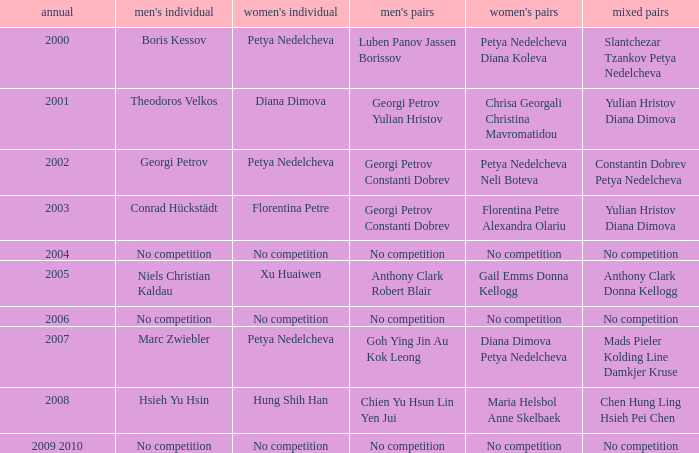Write the full table. {'header': ['annual', "men's individual", "women's individual", "men's pairs", "women's pairs", 'mixed pairs'], 'rows': [['2000', 'Boris Kessov', 'Petya Nedelcheva', 'Luben Panov Jassen Borissov', 'Petya Nedelcheva Diana Koleva', 'Slantchezar Tzankov Petya Nedelcheva'], ['2001', 'Theodoros Velkos', 'Diana Dimova', 'Georgi Petrov Yulian Hristov', 'Chrisa Georgali Christina Mavromatidou', 'Yulian Hristov Diana Dimova'], ['2002', 'Georgi Petrov', 'Petya Nedelcheva', 'Georgi Petrov Constanti Dobrev', 'Petya Nedelcheva Neli Boteva', 'Constantin Dobrev Petya Nedelcheva'], ['2003', 'Conrad Hückstädt', 'Florentina Petre', 'Georgi Petrov Constanti Dobrev', 'Florentina Petre Alexandra Olariu', 'Yulian Hristov Diana Dimova'], ['2004', 'No competition', 'No competition', 'No competition', 'No competition', 'No competition'], ['2005', 'Niels Christian Kaldau', 'Xu Huaiwen', 'Anthony Clark Robert Blair', 'Gail Emms Donna Kellogg', 'Anthony Clark Donna Kellogg'], ['2006', 'No competition', 'No competition', 'No competition', 'No competition', 'No competition'], ['2007', 'Marc Zwiebler', 'Petya Nedelcheva', 'Goh Ying Jin Au Kok Leong', 'Diana Dimova Petya Nedelcheva', 'Mads Pieler Kolding Line Damkjer Kruse'], ['2008', 'Hsieh Yu Hsin', 'Hung Shih Han', 'Chien Yu Hsun Lin Yen Jui', 'Maria Helsbol Anne Skelbaek', 'Chen Hung Ling Hsieh Pei Chen'], ['2009 2010', 'No competition', 'No competition', 'No competition', 'No competition', 'No competition']]} Who won the Men's Double the same year as Florentina Petre winning the Women's Singles? Georgi Petrov Constanti Dobrev. 